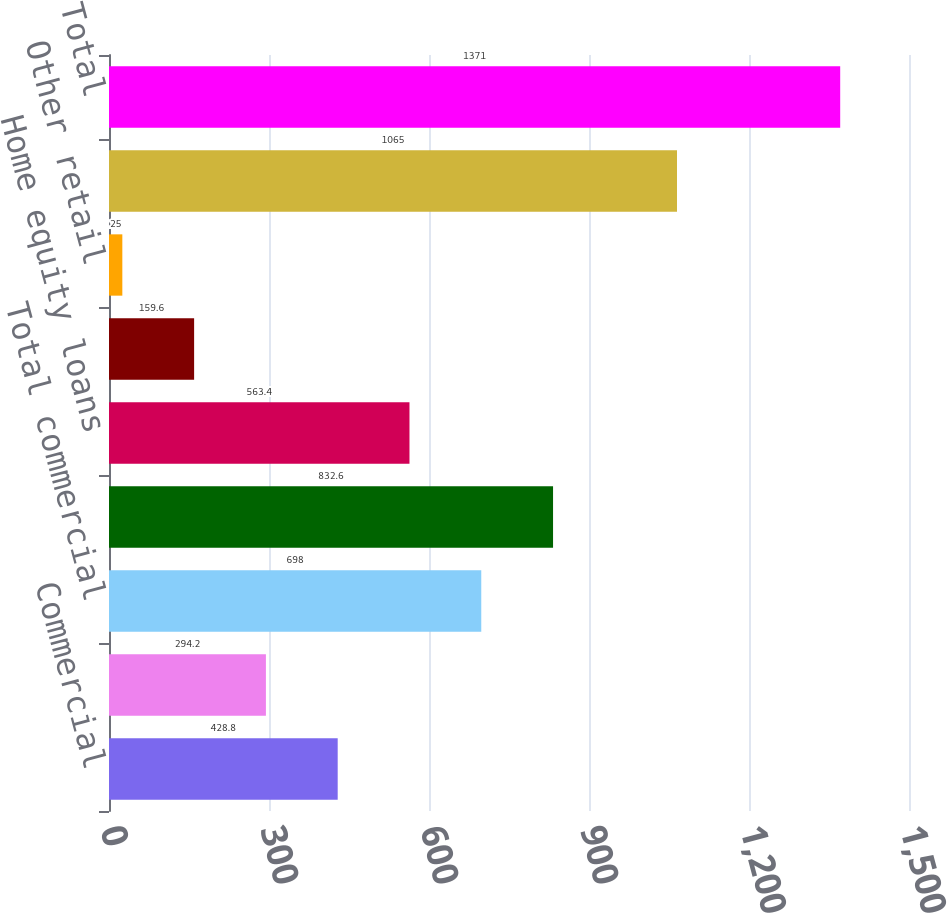<chart> <loc_0><loc_0><loc_500><loc_500><bar_chart><fcel>Commercial<fcel>Commercial real estate<fcel>Total commercial<fcel>Residential mortgages<fcel>Home equity loans<fcel>Home equity loans serviced by<fcel>Other retail<fcel>Total retail<fcel>Total<nl><fcel>428.8<fcel>294.2<fcel>698<fcel>832.6<fcel>563.4<fcel>159.6<fcel>25<fcel>1065<fcel>1371<nl></chart> 